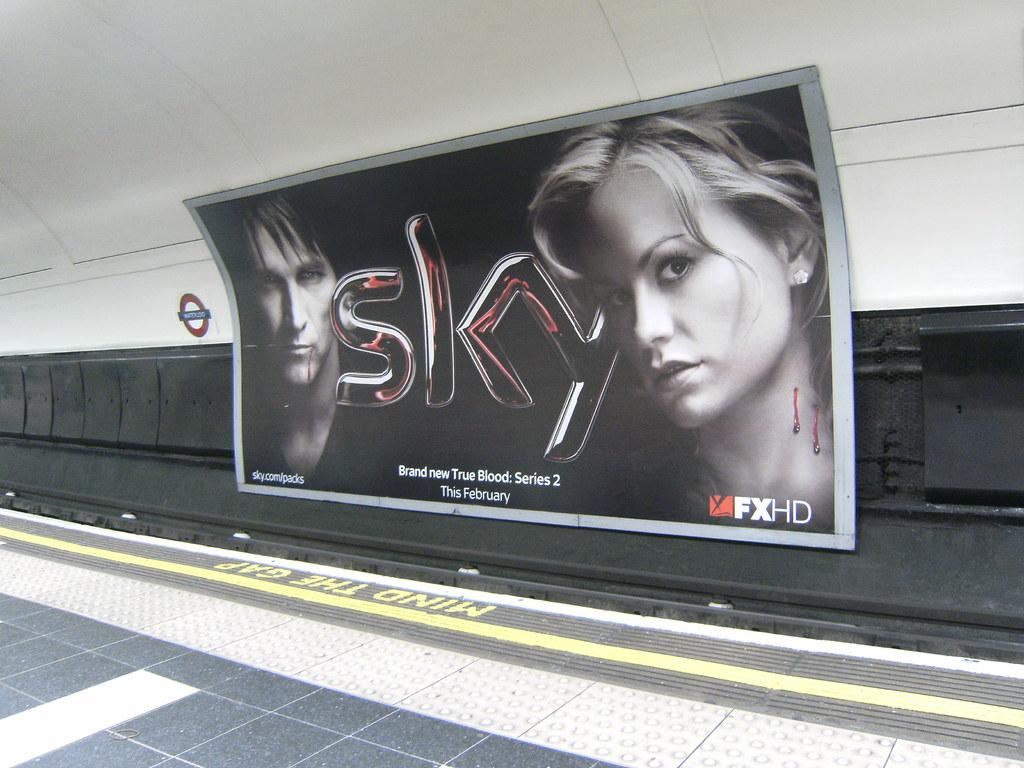What is the main object in the image? There is a banner in the image. What is written on the banner? The word "sky" is written on the banner. What else can be seen on the banner besides the text? There are images of two people on the banner. What is located on the left side of the image? There is a signboard on the left side of the image. What color is the background of the image? The background of the image is white. What thought is expressed by the whistle in the image? There is no whistle present in the image, so it is not possible to determine any thoughts expressed by it. 